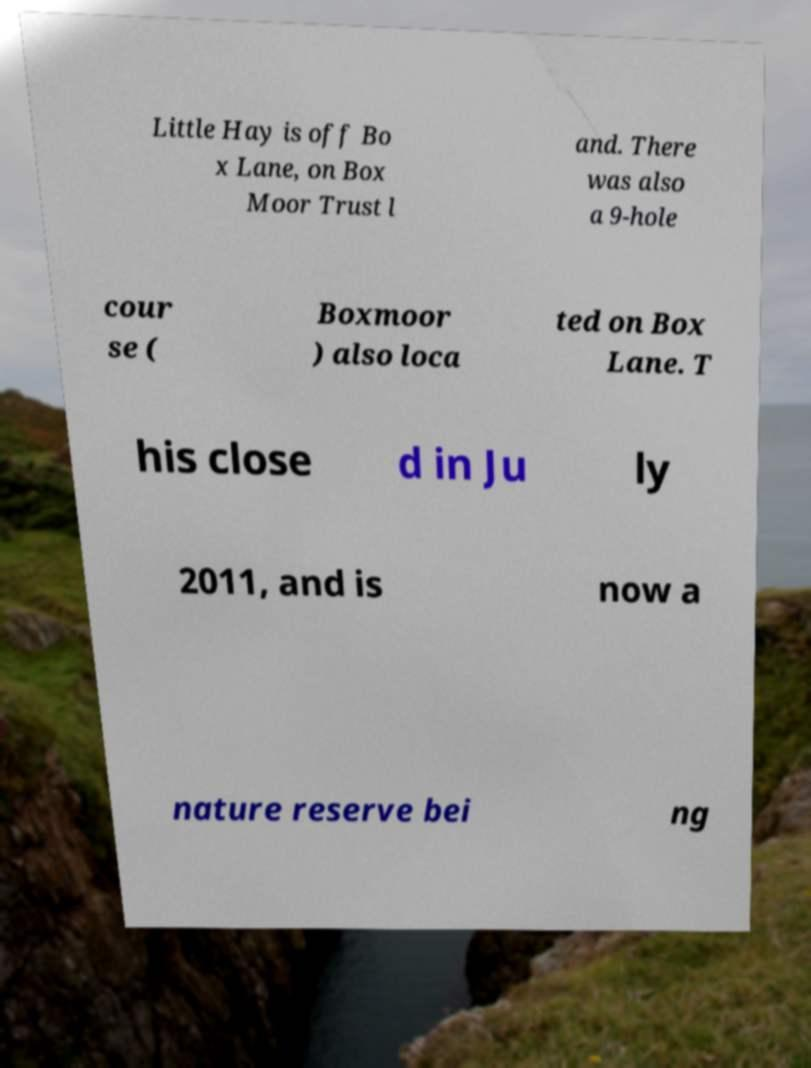Can you read and provide the text displayed in the image?This photo seems to have some interesting text. Can you extract and type it out for me? Little Hay is off Bo x Lane, on Box Moor Trust l and. There was also a 9-hole cour se ( Boxmoor ) also loca ted on Box Lane. T his close d in Ju ly 2011, and is now a nature reserve bei ng 